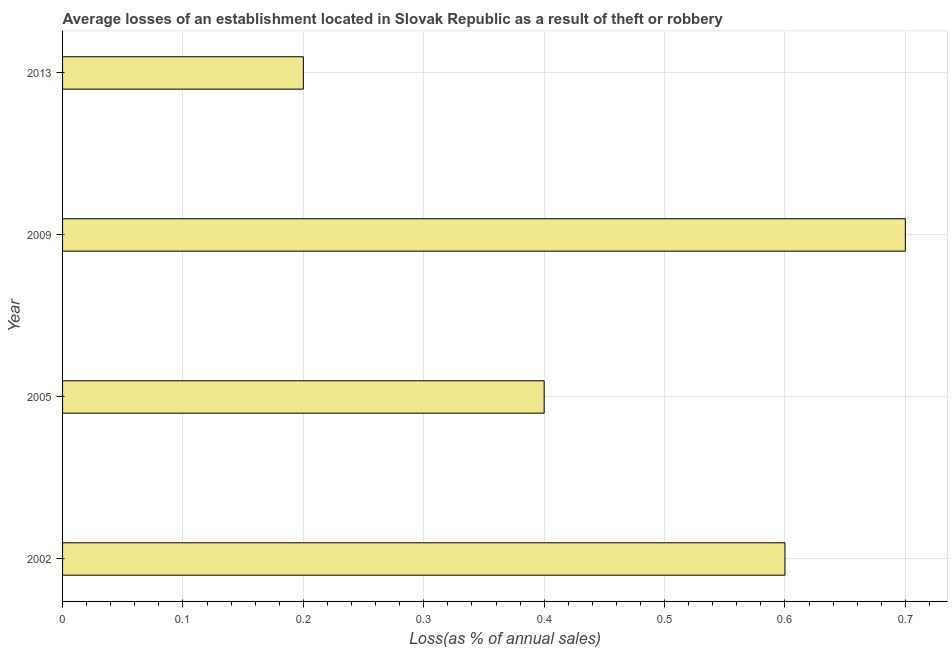Does the graph contain any zero values?
Offer a very short reply. No. Does the graph contain grids?
Keep it short and to the point. Yes. What is the title of the graph?
Your answer should be compact. Average losses of an establishment located in Slovak Republic as a result of theft or robbery. What is the label or title of the X-axis?
Ensure brevity in your answer.  Loss(as % of annual sales). Across all years, what is the maximum losses due to theft?
Offer a terse response. 0.7. In which year was the losses due to theft maximum?
Offer a very short reply. 2009. In which year was the losses due to theft minimum?
Ensure brevity in your answer.  2013. What is the difference between the losses due to theft in 2005 and 2013?
Ensure brevity in your answer.  0.2. What is the average losses due to theft per year?
Ensure brevity in your answer.  0.47. Do a majority of the years between 2013 and 2005 (inclusive) have losses due to theft greater than 0.66 %?
Offer a very short reply. Yes. What is the ratio of the losses due to theft in 2002 to that in 2005?
Your answer should be very brief. 1.5. What is the difference between the highest and the lowest losses due to theft?
Give a very brief answer. 0.5. In how many years, is the losses due to theft greater than the average losses due to theft taken over all years?
Provide a short and direct response. 2. Are all the bars in the graph horizontal?
Offer a very short reply. Yes. What is the difference between two consecutive major ticks on the X-axis?
Provide a succinct answer. 0.1. What is the Loss(as % of annual sales) in 2009?
Offer a very short reply. 0.7. What is the difference between the Loss(as % of annual sales) in 2002 and 2009?
Offer a terse response. -0.1. What is the difference between the Loss(as % of annual sales) in 2005 and 2009?
Keep it short and to the point. -0.3. What is the difference between the Loss(as % of annual sales) in 2005 and 2013?
Offer a terse response. 0.2. What is the difference between the Loss(as % of annual sales) in 2009 and 2013?
Ensure brevity in your answer.  0.5. What is the ratio of the Loss(as % of annual sales) in 2002 to that in 2009?
Provide a short and direct response. 0.86. What is the ratio of the Loss(as % of annual sales) in 2005 to that in 2009?
Your answer should be compact. 0.57. What is the ratio of the Loss(as % of annual sales) in 2009 to that in 2013?
Offer a very short reply. 3.5. 